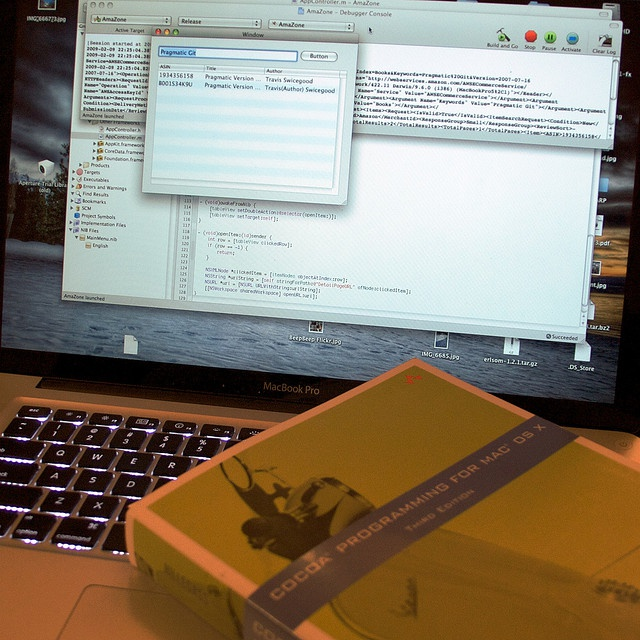Describe the objects in this image and their specific colors. I can see laptop in black, white, lightblue, and gray tones, book in black, maroon, and olive tones, and keyboard in black, maroon, and brown tones in this image. 